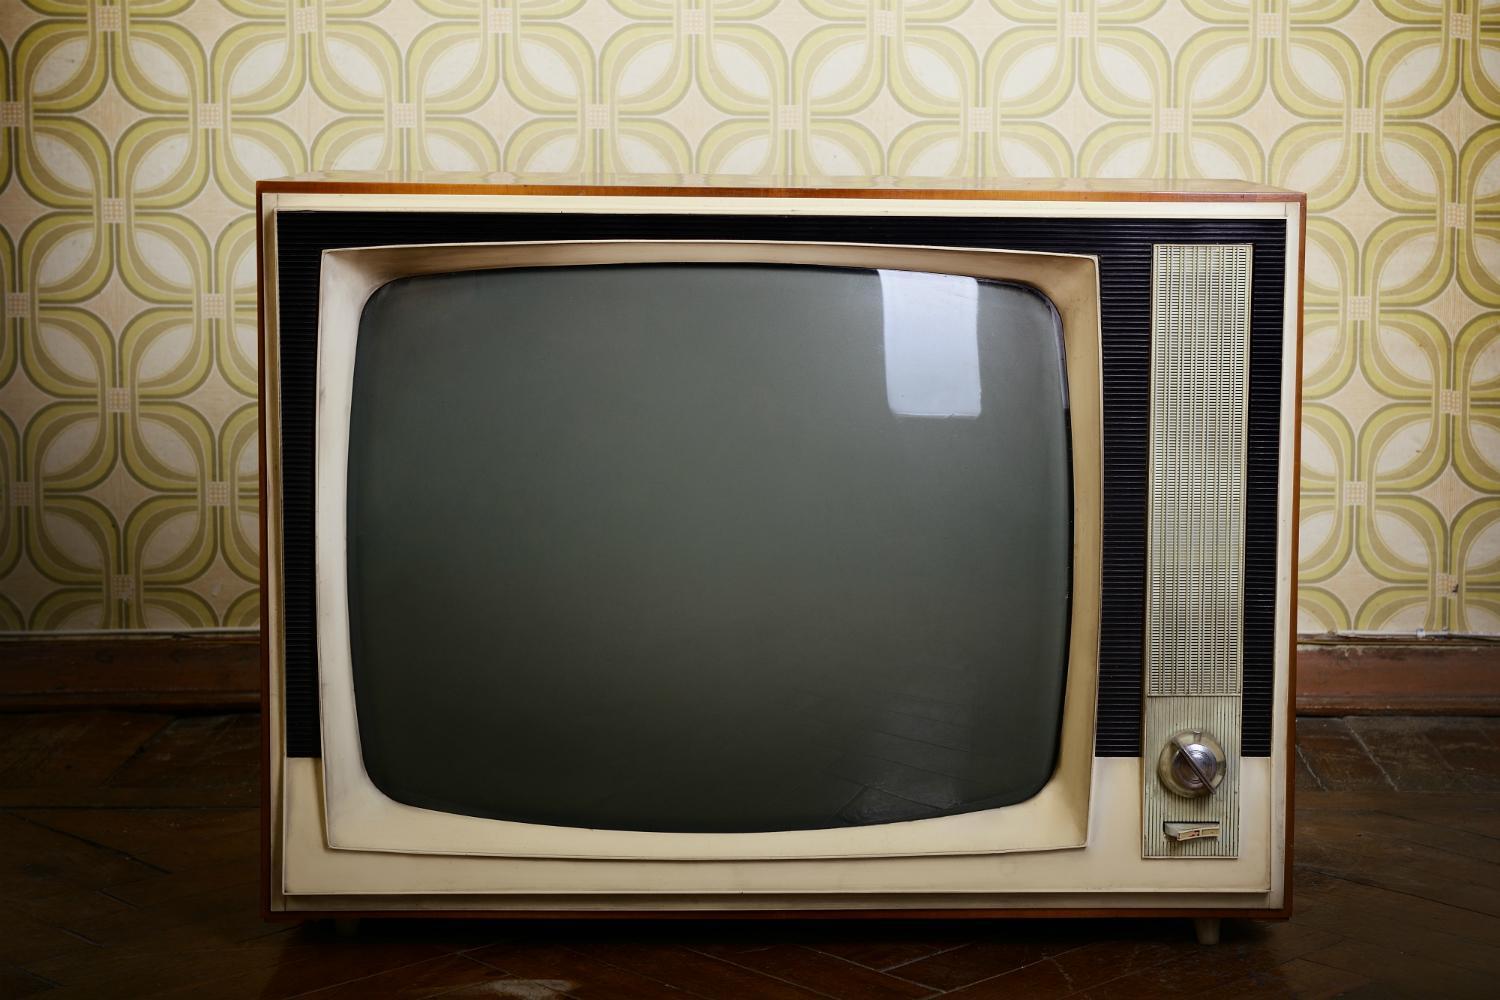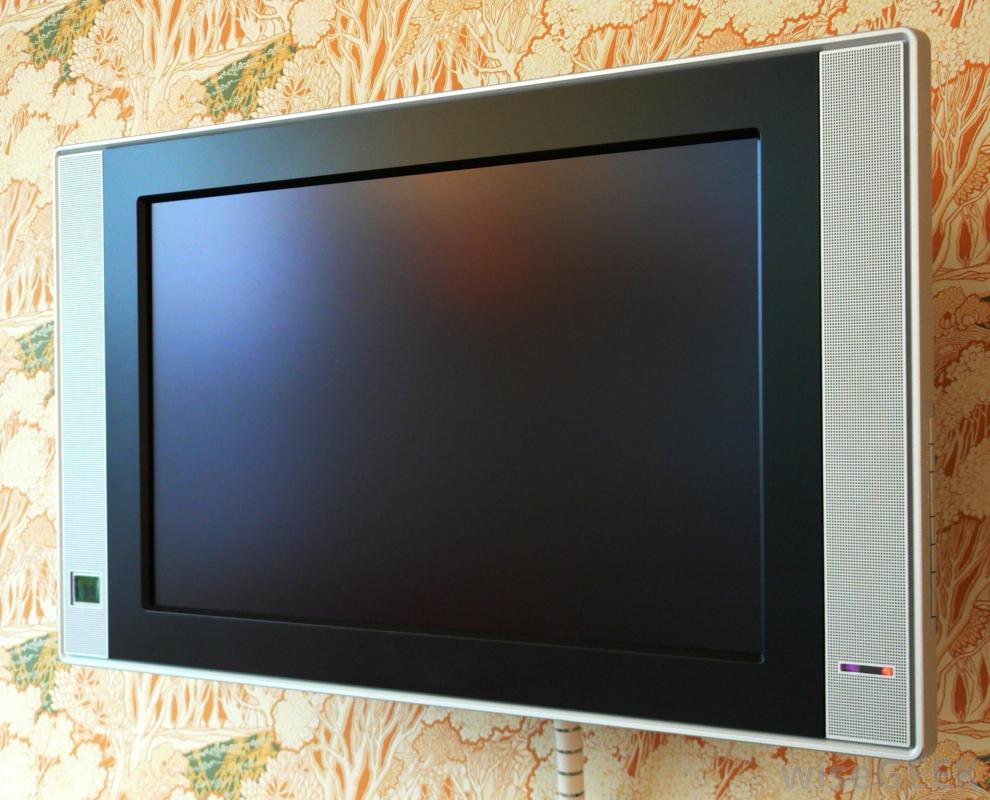The first image is the image on the left, the second image is the image on the right. For the images displayed, is the sentence "There are at least two round knobs on each television." factually correct? Answer yes or no. No. The first image is the image on the left, the second image is the image on the right. Given the left and right images, does the statement "The screen on one of the old-fashioned TVs is glowing, showing the set is turned on." hold true? Answer yes or no. No. 